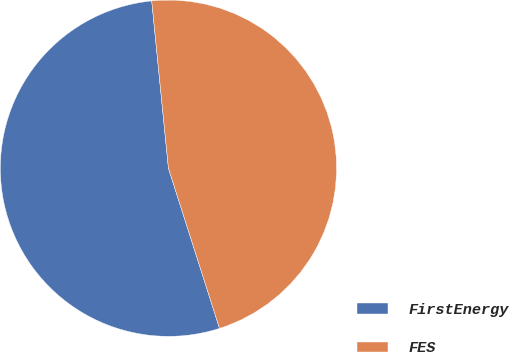Convert chart. <chart><loc_0><loc_0><loc_500><loc_500><pie_chart><fcel>FirstEnergy<fcel>FES<nl><fcel>53.33%<fcel>46.67%<nl></chart> 